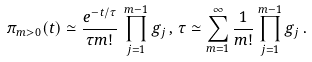<formula> <loc_0><loc_0><loc_500><loc_500>\pi _ { m > 0 } ( t ) \simeq \frac { e ^ { - t / \tau } } { \tau m ! } \, \prod _ { j = 1 } ^ { m - 1 } g _ { j } \, , \, \tau \simeq \sum _ { m = 1 } ^ { \infty } \frac { 1 } { m ! } \prod _ { j = 1 } ^ { m - 1 } g _ { j } \, .</formula> 